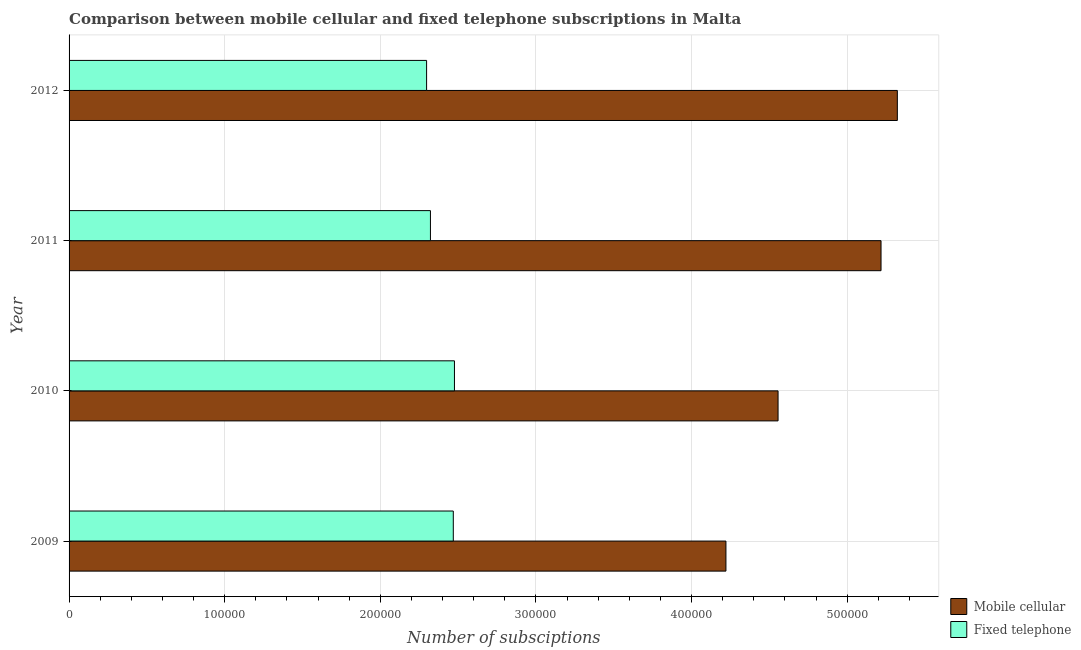How many bars are there on the 4th tick from the top?
Offer a terse response. 2. In how many cases, is the number of bars for a given year not equal to the number of legend labels?
Provide a succinct answer. 0. What is the number of mobile cellular subscriptions in 2010?
Provide a short and direct response. 4.56e+05. Across all years, what is the maximum number of fixed telephone subscriptions?
Keep it short and to the point. 2.48e+05. Across all years, what is the minimum number of fixed telephone subscriptions?
Your answer should be very brief. 2.30e+05. In which year was the number of fixed telephone subscriptions maximum?
Your answer should be compact. 2010. What is the total number of fixed telephone subscriptions in the graph?
Your answer should be very brief. 9.56e+05. What is the difference between the number of mobile cellular subscriptions in 2009 and that in 2011?
Your answer should be compact. -9.97e+04. What is the difference between the number of mobile cellular subscriptions in 2010 and the number of fixed telephone subscriptions in 2011?
Provide a short and direct response. 2.23e+05. What is the average number of fixed telephone subscriptions per year?
Make the answer very short. 2.39e+05. In the year 2010, what is the difference between the number of fixed telephone subscriptions and number of mobile cellular subscriptions?
Your answer should be very brief. -2.08e+05. In how many years, is the number of fixed telephone subscriptions greater than 200000 ?
Make the answer very short. 4. What is the ratio of the number of mobile cellular subscriptions in 2011 to that in 2012?
Ensure brevity in your answer.  0.98. What is the difference between the highest and the second highest number of fixed telephone subscriptions?
Keep it short and to the point. 745. What is the difference between the highest and the lowest number of fixed telephone subscriptions?
Provide a short and direct response. 1.79e+04. What does the 1st bar from the top in 2011 represents?
Give a very brief answer. Fixed telephone. What does the 2nd bar from the bottom in 2012 represents?
Make the answer very short. Fixed telephone. How many bars are there?
Give a very brief answer. 8. Are all the bars in the graph horizontal?
Your answer should be very brief. Yes. How many years are there in the graph?
Make the answer very short. 4. What is the difference between two consecutive major ticks on the X-axis?
Your answer should be very brief. 1.00e+05. Where does the legend appear in the graph?
Ensure brevity in your answer.  Bottom right. How are the legend labels stacked?
Offer a very short reply. Vertical. What is the title of the graph?
Offer a terse response. Comparison between mobile cellular and fixed telephone subscriptions in Malta. What is the label or title of the X-axis?
Provide a short and direct response. Number of subsciptions. What is the Number of subsciptions in Mobile cellular in 2009?
Give a very brief answer. 4.22e+05. What is the Number of subsciptions of Fixed telephone in 2009?
Offer a terse response. 2.47e+05. What is the Number of subsciptions in Mobile cellular in 2010?
Keep it short and to the point. 4.56e+05. What is the Number of subsciptions in Fixed telephone in 2010?
Ensure brevity in your answer.  2.48e+05. What is the Number of subsciptions of Mobile cellular in 2011?
Ensure brevity in your answer.  5.22e+05. What is the Number of subsciptions of Fixed telephone in 2011?
Your response must be concise. 2.32e+05. What is the Number of subsciptions in Mobile cellular in 2012?
Offer a very short reply. 5.32e+05. What is the Number of subsciptions of Fixed telephone in 2012?
Give a very brief answer. 2.30e+05. Across all years, what is the maximum Number of subsciptions of Mobile cellular?
Ensure brevity in your answer.  5.32e+05. Across all years, what is the maximum Number of subsciptions in Fixed telephone?
Provide a short and direct response. 2.48e+05. Across all years, what is the minimum Number of subsciptions of Mobile cellular?
Make the answer very short. 4.22e+05. Across all years, what is the minimum Number of subsciptions of Fixed telephone?
Provide a short and direct response. 2.30e+05. What is the total Number of subsciptions in Mobile cellular in the graph?
Offer a very short reply. 1.93e+06. What is the total Number of subsciptions in Fixed telephone in the graph?
Make the answer very short. 9.56e+05. What is the difference between the Number of subsciptions of Mobile cellular in 2009 and that in 2010?
Offer a very short reply. -3.35e+04. What is the difference between the Number of subsciptions of Fixed telephone in 2009 and that in 2010?
Your answer should be compact. -745. What is the difference between the Number of subsciptions of Mobile cellular in 2009 and that in 2011?
Keep it short and to the point. -9.97e+04. What is the difference between the Number of subsciptions of Fixed telephone in 2009 and that in 2011?
Give a very brief answer. 1.47e+04. What is the difference between the Number of subsciptions of Mobile cellular in 2009 and that in 2012?
Offer a terse response. -1.10e+05. What is the difference between the Number of subsciptions in Fixed telephone in 2009 and that in 2012?
Keep it short and to the point. 1.72e+04. What is the difference between the Number of subsciptions of Mobile cellular in 2010 and that in 2011?
Offer a very short reply. -6.62e+04. What is the difference between the Number of subsciptions of Fixed telephone in 2010 and that in 2011?
Make the answer very short. 1.54e+04. What is the difference between the Number of subsciptions in Mobile cellular in 2010 and that in 2012?
Your answer should be compact. -7.66e+04. What is the difference between the Number of subsciptions of Fixed telephone in 2010 and that in 2012?
Make the answer very short. 1.79e+04. What is the difference between the Number of subsciptions in Mobile cellular in 2011 and that in 2012?
Your answer should be very brief. -1.05e+04. What is the difference between the Number of subsciptions of Fixed telephone in 2011 and that in 2012?
Ensure brevity in your answer.  2463. What is the difference between the Number of subsciptions of Mobile cellular in 2009 and the Number of subsciptions of Fixed telephone in 2010?
Offer a very short reply. 1.74e+05. What is the difference between the Number of subsciptions of Mobile cellular in 2009 and the Number of subsciptions of Fixed telephone in 2011?
Give a very brief answer. 1.90e+05. What is the difference between the Number of subsciptions in Mobile cellular in 2009 and the Number of subsciptions in Fixed telephone in 2012?
Offer a terse response. 1.92e+05. What is the difference between the Number of subsciptions in Mobile cellular in 2010 and the Number of subsciptions in Fixed telephone in 2011?
Give a very brief answer. 2.23e+05. What is the difference between the Number of subsciptions of Mobile cellular in 2010 and the Number of subsciptions of Fixed telephone in 2012?
Keep it short and to the point. 2.26e+05. What is the difference between the Number of subsciptions of Mobile cellular in 2011 and the Number of subsciptions of Fixed telephone in 2012?
Make the answer very short. 2.92e+05. What is the average Number of subsciptions in Mobile cellular per year?
Give a very brief answer. 4.83e+05. What is the average Number of subsciptions in Fixed telephone per year?
Provide a short and direct response. 2.39e+05. In the year 2009, what is the difference between the Number of subsciptions in Mobile cellular and Number of subsciptions in Fixed telephone?
Your answer should be very brief. 1.75e+05. In the year 2010, what is the difference between the Number of subsciptions in Mobile cellular and Number of subsciptions in Fixed telephone?
Your answer should be very brief. 2.08e+05. In the year 2011, what is the difference between the Number of subsciptions of Mobile cellular and Number of subsciptions of Fixed telephone?
Make the answer very short. 2.90e+05. In the year 2012, what is the difference between the Number of subsciptions of Mobile cellular and Number of subsciptions of Fixed telephone?
Give a very brief answer. 3.02e+05. What is the ratio of the Number of subsciptions of Mobile cellular in 2009 to that in 2010?
Your response must be concise. 0.93. What is the ratio of the Number of subsciptions in Fixed telephone in 2009 to that in 2010?
Keep it short and to the point. 1. What is the ratio of the Number of subsciptions in Mobile cellular in 2009 to that in 2011?
Provide a short and direct response. 0.81. What is the ratio of the Number of subsciptions in Fixed telephone in 2009 to that in 2011?
Your answer should be compact. 1.06. What is the ratio of the Number of subsciptions in Mobile cellular in 2009 to that in 2012?
Provide a succinct answer. 0.79. What is the ratio of the Number of subsciptions of Fixed telephone in 2009 to that in 2012?
Your answer should be very brief. 1.07. What is the ratio of the Number of subsciptions in Mobile cellular in 2010 to that in 2011?
Your response must be concise. 0.87. What is the ratio of the Number of subsciptions in Fixed telephone in 2010 to that in 2011?
Make the answer very short. 1.07. What is the ratio of the Number of subsciptions of Mobile cellular in 2010 to that in 2012?
Provide a short and direct response. 0.86. What is the ratio of the Number of subsciptions of Fixed telephone in 2010 to that in 2012?
Provide a succinct answer. 1.08. What is the ratio of the Number of subsciptions of Mobile cellular in 2011 to that in 2012?
Your response must be concise. 0.98. What is the ratio of the Number of subsciptions in Fixed telephone in 2011 to that in 2012?
Your answer should be very brief. 1.01. What is the difference between the highest and the second highest Number of subsciptions in Mobile cellular?
Your answer should be very brief. 1.05e+04. What is the difference between the highest and the second highest Number of subsciptions of Fixed telephone?
Make the answer very short. 745. What is the difference between the highest and the lowest Number of subsciptions in Mobile cellular?
Your response must be concise. 1.10e+05. What is the difference between the highest and the lowest Number of subsciptions of Fixed telephone?
Your answer should be compact. 1.79e+04. 